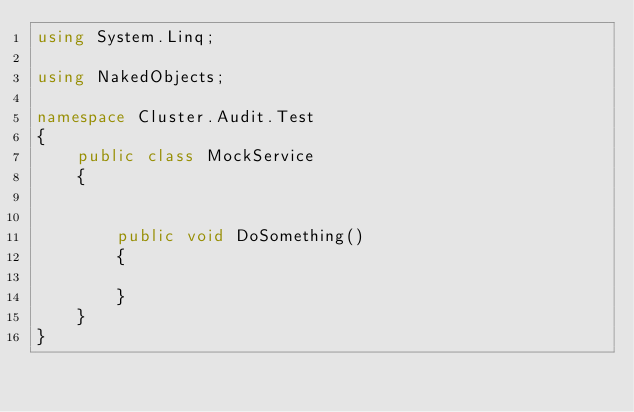Convert code to text. <code><loc_0><loc_0><loc_500><loc_500><_C#_>using System.Linq;

using NakedObjects;

namespace Cluster.Audit.Test
{
    public class MockService
    {


        public void DoSomething()
        {
            
        }
    }
}

</code> 